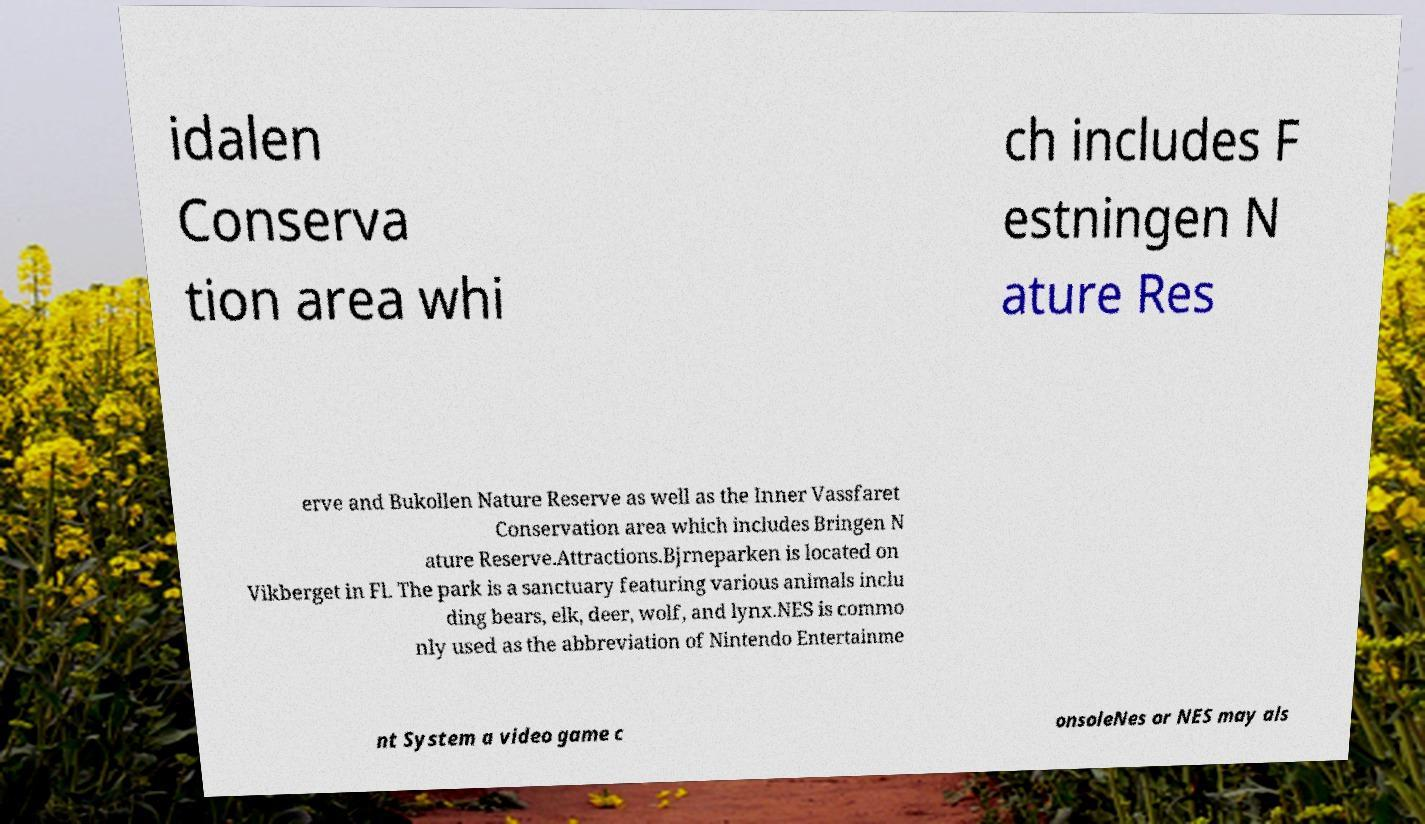Please read and relay the text visible in this image. What does it say? idalen Conserva tion area whi ch includes F estningen N ature Res erve and Bukollen Nature Reserve as well as the Inner Vassfaret Conservation area which includes Bringen N ature Reserve.Attractions.Bjrneparken is located on Vikberget in Fl. The park is a sanctuary featuring various animals inclu ding bears, elk, deer, wolf, and lynx.NES is commo nly used as the abbreviation of Nintendo Entertainme nt System a video game c onsoleNes or NES may als 